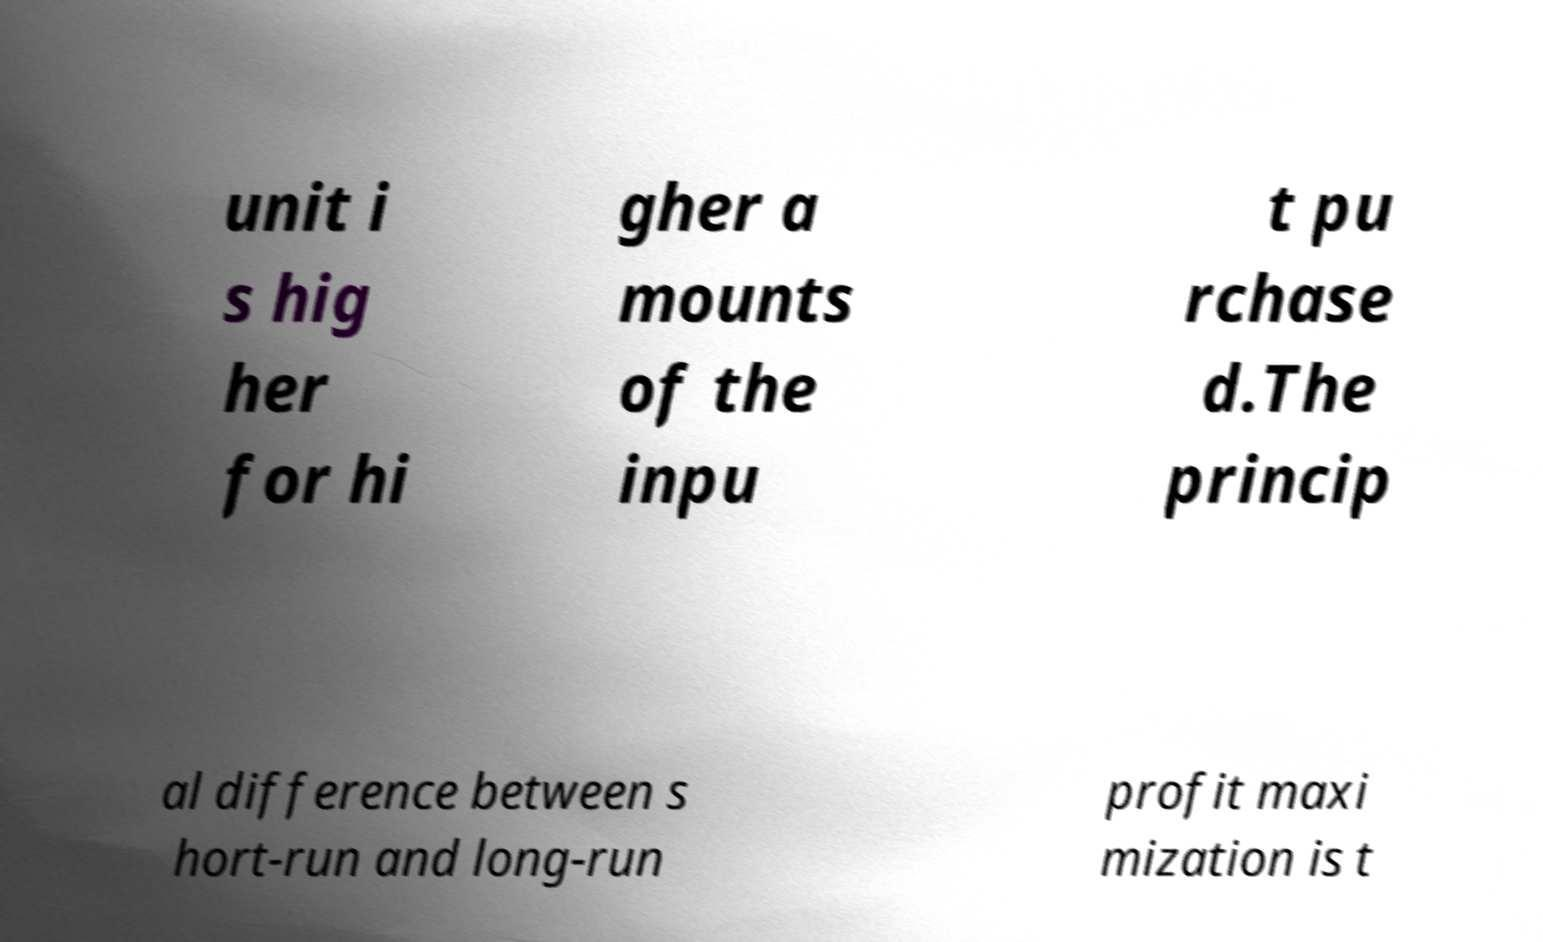Please read and relay the text visible in this image. What does it say? unit i s hig her for hi gher a mounts of the inpu t pu rchase d.The princip al difference between s hort-run and long-run profit maxi mization is t 